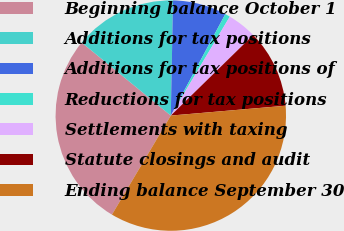Convert chart. <chart><loc_0><loc_0><loc_500><loc_500><pie_chart><fcel>Beginning balance October 1<fcel>Additions for tax positions<fcel>Additions for tax positions of<fcel>Reductions for tax positions<fcel>Settlements with taxing<fcel>Statute closings and audit<fcel>Ending balance September 30<nl><fcel>27.39%<fcel>14.38%<fcel>7.54%<fcel>0.71%<fcel>4.12%<fcel>10.96%<fcel>34.89%<nl></chart> 